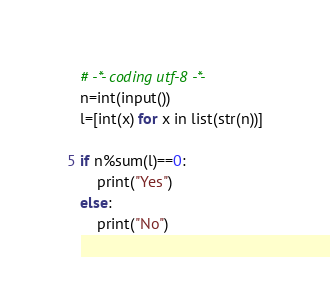Convert code to text. <code><loc_0><loc_0><loc_500><loc_500><_Python_># -*- coding utf-8 -*-
n=int(input())
l=[int(x) for x in list(str(n))]

if n%sum(l)==0:
    print("Yes")
else:
    print("No")
</code> 